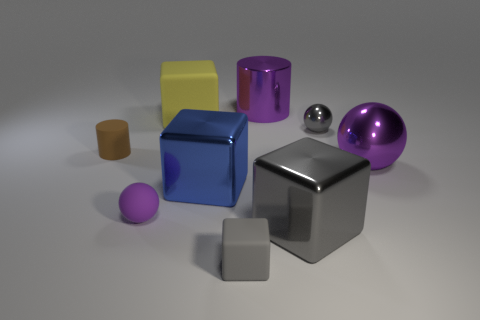Subtract all gray cubes. How many were subtracted if there are1gray cubes left? 1 Subtract all green cubes. Subtract all brown spheres. How many cubes are left? 4 Add 1 cyan matte blocks. How many objects exist? 10 Subtract all blocks. How many objects are left? 5 Add 3 large blue blocks. How many large blue blocks exist? 4 Subtract 0 blue spheres. How many objects are left? 9 Subtract all small purple metal cylinders. Subtract all big rubber objects. How many objects are left? 8 Add 1 purple cylinders. How many purple cylinders are left? 2 